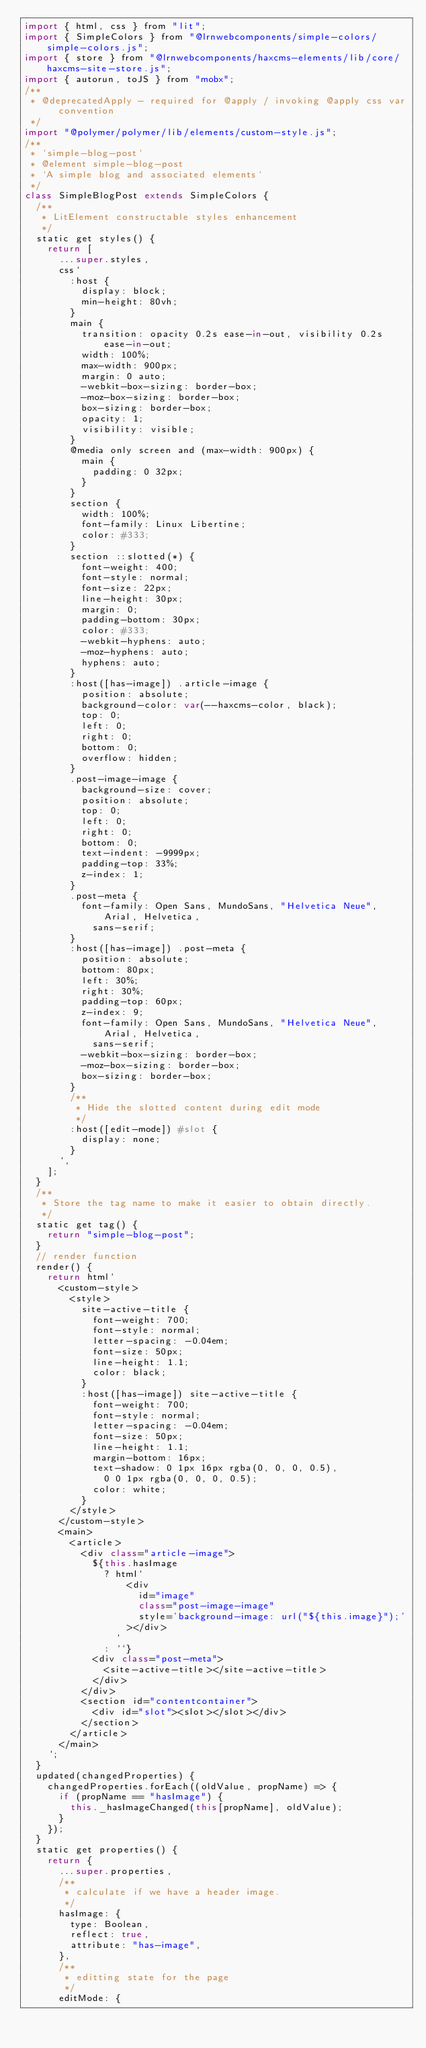Convert code to text. <code><loc_0><loc_0><loc_500><loc_500><_JavaScript_>import { html, css } from "lit";
import { SimpleColors } from "@lrnwebcomponents/simple-colors/simple-colors.js";
import { store } from "@lrnwebcomponents/haxcms-elements/lib/core/haxcms-site-store.js";
import { autorun, toJS } from "mobx";
/**
 * @deprecatedApply - required for @apply / invoking @apply css var convention
 */
import "@polymer/polymer/lib/elements/custom-style.js";
/**
 * `simple-blog-post`
 * @element simple-blog-post
 * `A simple blog and associated elements`
 */
class SimpleBlogPost extends SimpleColors {
  /**
   * LitElement constructable styles enhancement
   */
  static get styles() {
    return [
      ...super.styles,
      css`
        :host {
          display: block;
          min-height: 80vh;
        }
        main {
          transition: opacity 0.2s ease-in-out, visibility 0.2s ease-in-out;
          width: 100%;
          max-width: 900px;
          margin: 0 auto;
          -webkit-box-sizing: border-box;
          -moz-box-sizing: border-box;
          box-sizing: border-box;
          opacity: 1;
          visibility: visible;
        }
        @media only screen and (max-width: 900px) {
          main {
            padding: 0 32px;
          }
        }
        section {
          width: 100%;
          font-family: Linux Libertine;
          color: #333;
        }
        section ::slotted(*) {
          font-weight: 400;
          font-style: normal;
          font-size: 22px;
          line-height: 30px;
          margin: 0;
          padding-bottom: 30px;
          color: #333;
          -webkit-hyphens: auto;
          -moz-hyphens: auto;
          hyphens: auto;
        }
        :host([has-image]) .article-image {
          position: absolute;
          background-color: var(--haxcms-color, black);
          top: 0;
          left: 0;
          right: 0;
          bottom: 0;
          overflow: hidden;
        }
        .post-image-image {
          background-size: cover;
          position: absolute;
          top: 0;
          left: 0;
          right: 0;
          bottom: 0;
          text-indent: -9999px;
          padding-top: 33%;
          z-index: 1;
        }
        .post-meta {
          font-family: Open Sans, MundoSans, "Helvetica Neue", Arial, Helvetica,
            sans-serif;
        }
        :host([has-image]) .post-meta {
          position: absolute;
          bottom: 80px;
          left: 30%;
          right: 30%;
          padding-top: 60px;
          z-index: 9;
          font-family: Open Sans, MundoSans, "Helvetica Neue", Arial, Helvetica,
            sans-serif;
          -webkit-box-sizing: border-box;
          -moz-box-sizing: border-box;
          box-sizing: border-box;
        }
        /**
         * Hide the slotted content during edit mode
         */
        :host([edit-mode]) #slot {
          display: none;
        }
      `,
    ];
  }
  /**
   * Store the tag name to make it easier to obtain directly.
   */
  static get tag() {
    return "simple-blog-post";
  }
  // render function
  render() {
    return html`
      <custom-style>
        <style>
          site-active-title {
            font-weight: 700;
            font-style: normal;
            letter-spacing: -0.04em;
            font-size: 50px;
            line-height: 1.1;
            color: black;
          }
          :host([has-image]) site-active-title {
            font-weight: 700;
            font-style: normal;
            letter-spacing: -0.04em;
            font-size: 50px;
            line-height: 1.1;
            margin-bottom: 16px;
            text-shadow: 0 1px 16px rgba(0, 0, 0, 0.5),
              0 0 1px rgba(0, 0, 0, 0.5);
            color: white;
          }
        </style>
      </custom-style>
      <main>
        <article>
          <div class="article-image">
            ${this.hasImage
              ? html`
                  <div
                    id="image"
                    class="post-image-image"
                    style='background-image: url("${this.image}");'
                  ></div>
                `
              : ``}
            <div class="post-meta">
              <site-active-title></site-active-title>
            </div>
          </div>
          <section id="contentcontainer">
            <div id="slot"><slot></slot></div>
          </section>
        </article>
      </main>
    `;
  }
  updated(changedProperties) {
    changedProperties.forEach((oldValue, propName) => {
      if (propName == "hasImage") {
        this._hasImageChanged(this[propName], oldValue);
      }
    });
  }
  static get properties() {
    return {
      ...super.properties,
      /**
       * calculate if we have a header image.
       */
      hasImage: {
        type: Boolean,
        reflect: true,
        attribute: "has-image",
      },
      /**
       * editting state for the page
       */
      editMode: {</code> 